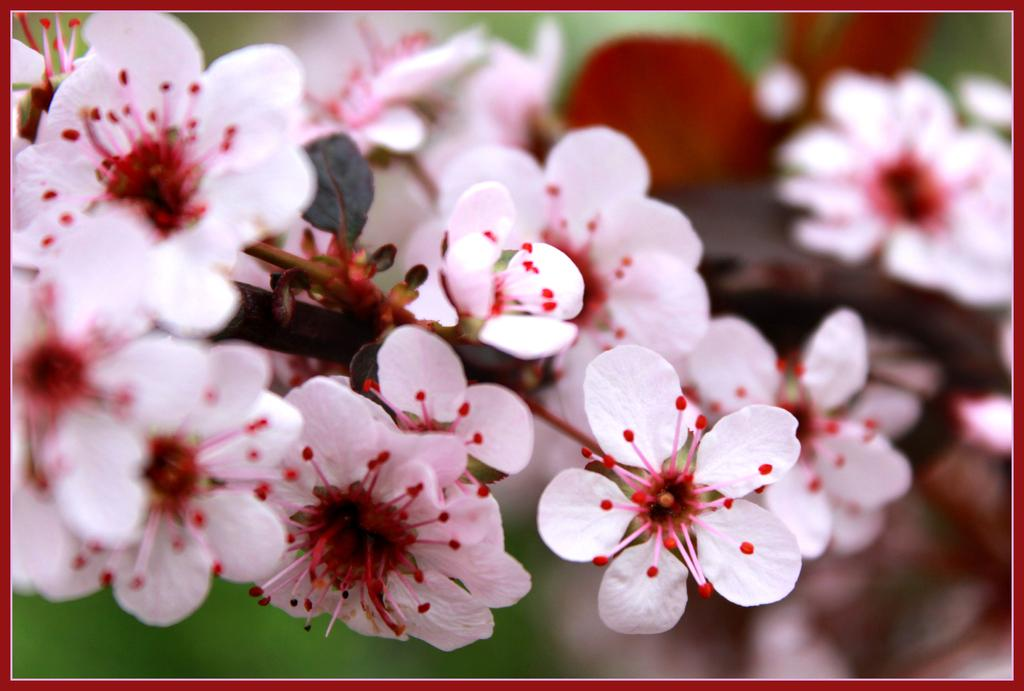What type of living organisms can be seen in the image? Flowers can be seen in the image. How does the zebra kick the ball in the image? There is no zebra or ball present in the image; it features flowers. 